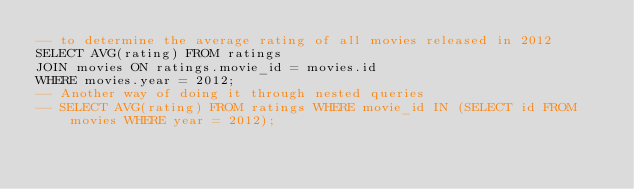<code> <loc_0><loc_0><loc_500><loc_500><_SQL_>-- to determine the average rating of all movies released in 2012
SELECT AVG(rating) FROM ratings
JOIN movies ON ratings.movie_id = movies.id
WHERE movies.year = 2012;
-- Another way of doing it through nested queries
-- SELECT AVG(rating) FROM ratings WHERE movie_id IN (SELECT id FROM movies WHERE year = 2012);</code> 